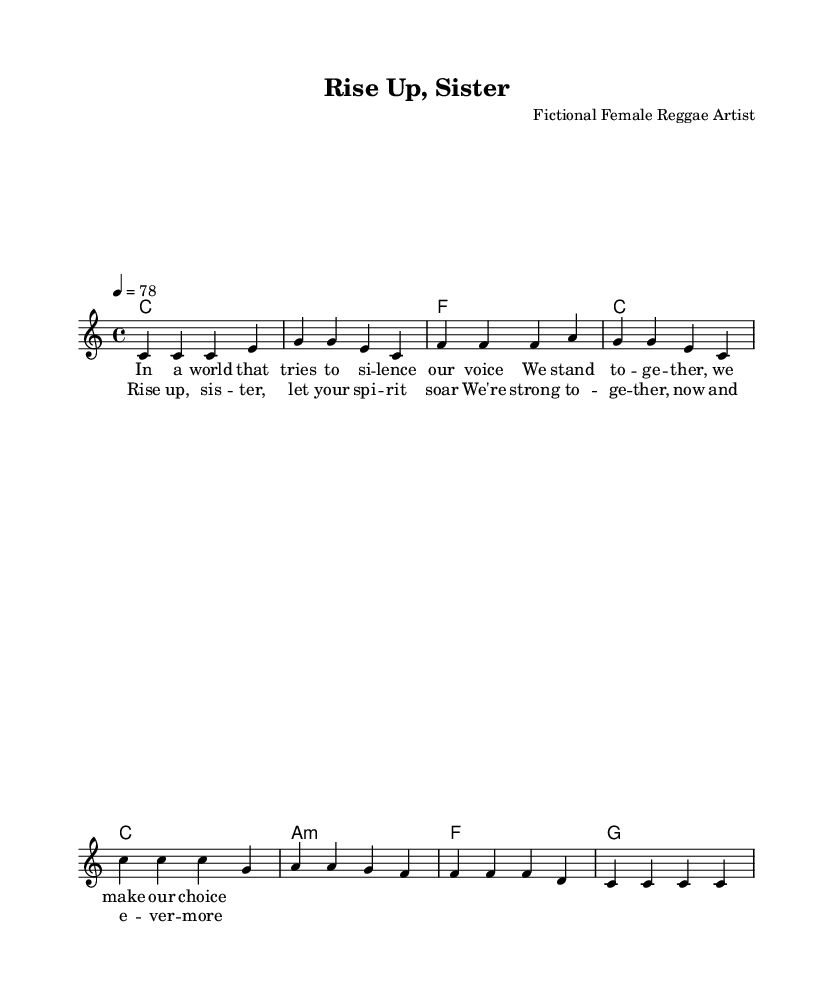What is the key signature of this music? The key signature is indicated at the beginning of the staff and shows C major, which has no sharps or flats.
Answer: C major What is the time signature of this music? The time signature is located at the beginning of the score and is shown as 4/4, meaning there are four beats per measure.
Answer: 4/4 What is the tempo marking for this piece? The tempo marking is provided after the time signature as "4 = 78", indicating that there are 78 beats per minute.
Answer: 78 How many measures does the verse section contain? The verse section contains four measures, as indicated by the grouping of notes and bars.
Answer: 4 What is the first word of the chorus lyrics? The chorus lyrics start with the word "Rise", which is the first word noted in the lyric section corresponding to the chorus.
Answer: Rise What chord is played during the chorus's first measure? The first chord in the chorus is indicated in the harmonies section, which shows C major for the whole measure.
Answer: C What theme do the lyrics predominantly convey? The lyrics focus on women's empowerment and unity, which is evident in the phrases and language used throughout the lyric section.
Answer: Empowerment 